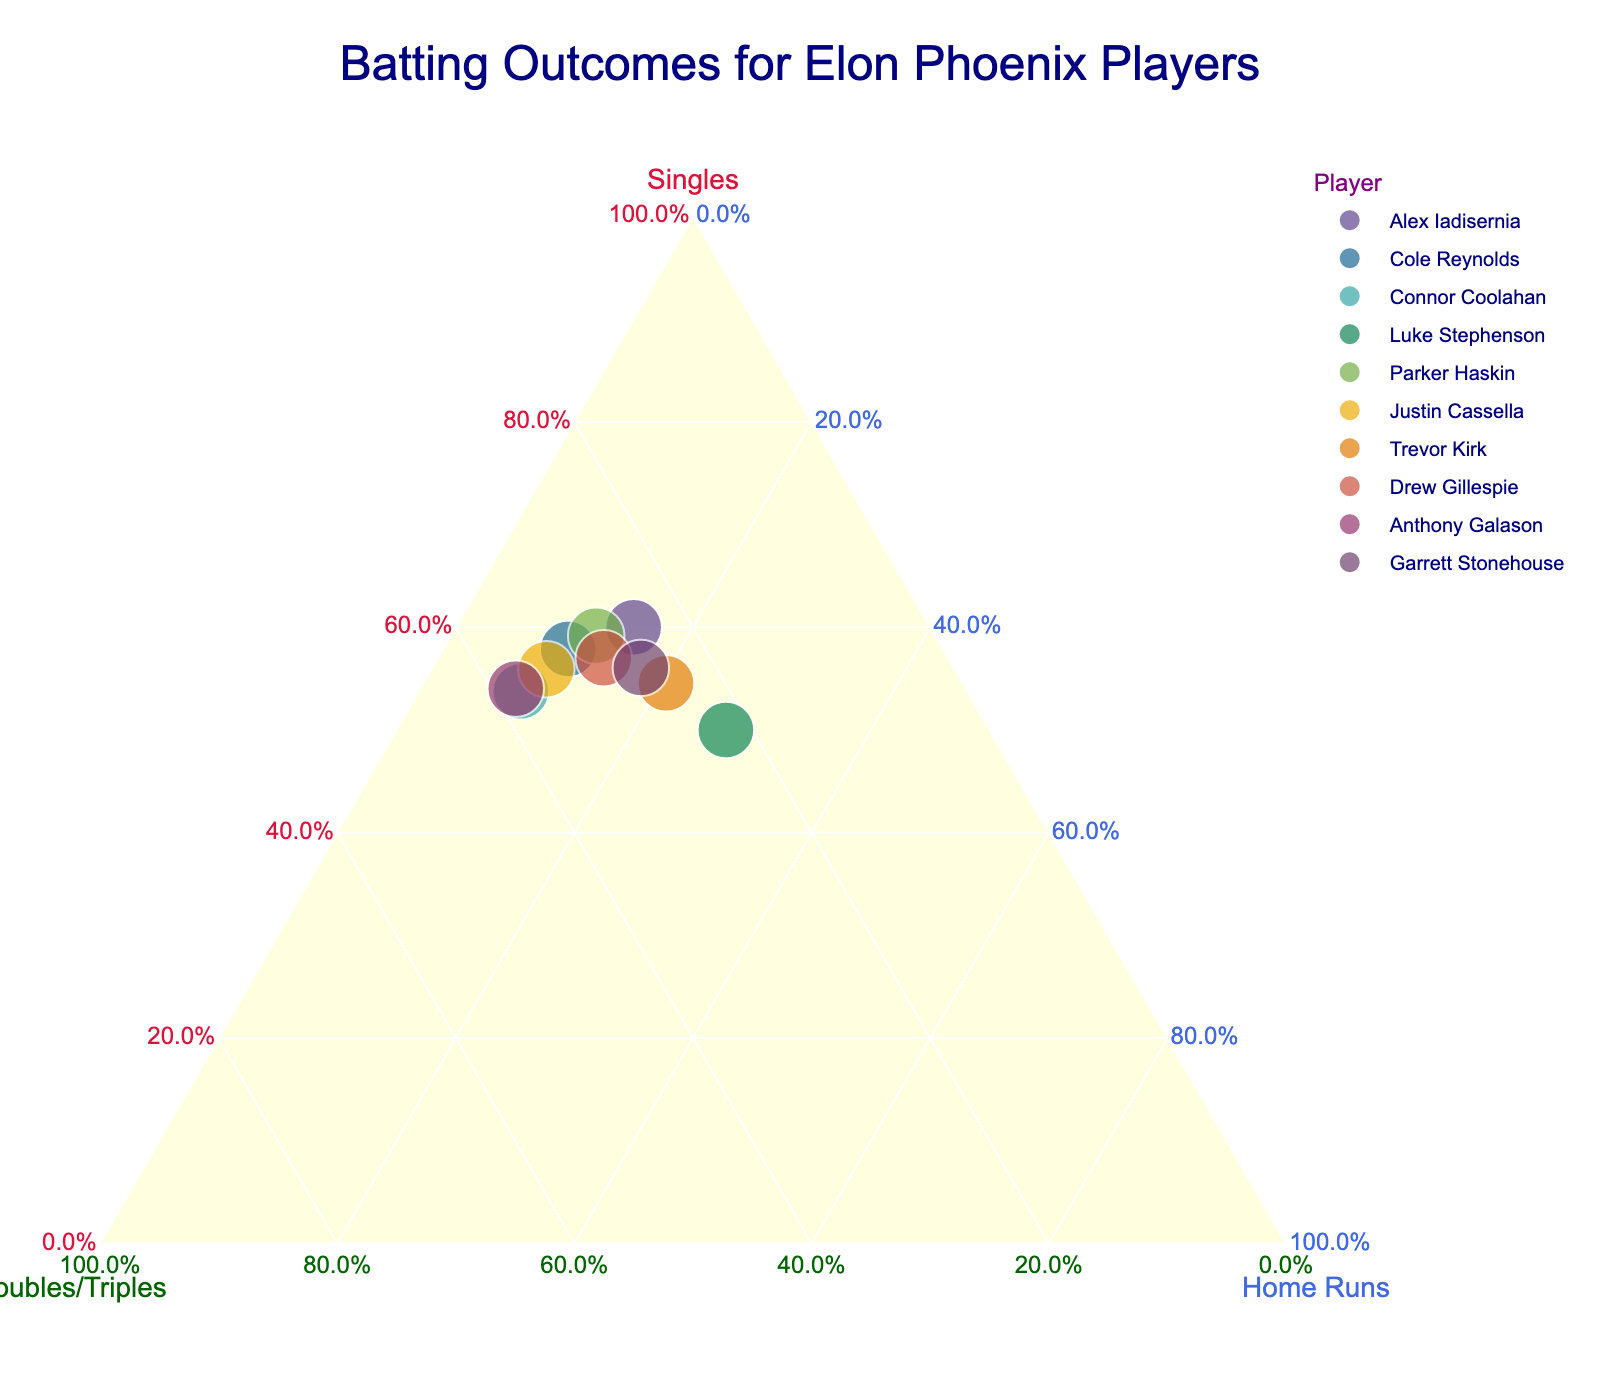What's the title of the plot? The title is usually located at the top center of the plot. By looking at this specific figure, you can read the title directly.
Answer: "Batting Outcomes for Elon Phoenix Players" How many players are displayed in the plot? Count the number of distinct points, each representing one player, on the ternary plot.
Answer: 10 Which player has the highest proportion of home runs? Find the point that is positioned closest to the "Home Runs" axis.
Answer: Luke Stephenson Do any players have an equal proportion of singles and doubles/triples? Look for a player whose point lies on the line equidistant from the "Singles" and "Doubles/Triples" axes.
Answer: No What is the color of the point representing Parker Haskin? Each player is represented by a different color, which can be identified by looking up the point labeled "Parker Haskin."
Answer: Not specified (depends on plot color palette) Which two players have the closest proportions of singles and home runs? Identify the players with points that are the nearest to each other in the plot, taking into account the distances from both the "Singles" and "Home Runs" axes.
Answer: Justin Cassella and Drew Gillespie How does the proportion of doubles/triples for Cole Reynolds compare to that of Anthony Galason? Compare the positions of Cole Reynolds and Anthony Galason along the "Doubles/Triples" axis.
Answer: Cole Reynolds has a lower proportion Which player has the most balanced distribution among singles, doubles/triples, and home runs? Look for the player whose point is closest to the center of the ternary plot.
Answer: Connor Coolahan How do Trevor Kirk's and Garrett Stonehouse's batting outcomes differ in terms of singles percentage? Compare their positions along the "Singles" axis and determine which one is farther to the side for singles.
Answer: Trevor Kirk has a lower percentage What is the overall trend in the distribution of batting outcomes for the players? Observe the general pattern or clustering of points—are they spread evenly or grouped towards one axis?
Answer: They are variably distributed, with no strong clustering towards one axis 